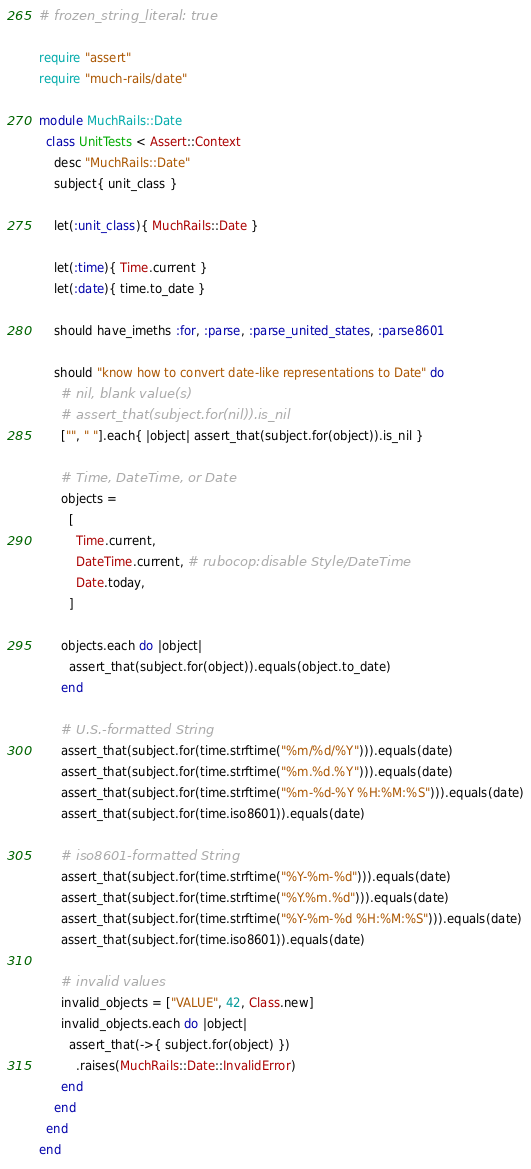<code> <loc_0><loc_0><loc_500><loc_500><_Ruby_># frozen_string_literal: true

require "assert"
require "much-rails/date"

module MuchRails::Date
  class UnitTests < Assert::Context
    desc "MuchRails::Date"
    subject{ unit_class }

    let(:unit_class){ MuchRails::Date }

    let(:time){ Time.current }
    let(:date){ time.to_date }

    should have_imeths :for, :parse, :parse_united_states, :parse8601

    should "know how to convert date-like representations to Date" do
      # nil, blank value(s)
      # assert_that(subject.for(nil)).is_nil
      ["", " "].each{ |object| assert_that(subject.for(object)).is_nil }

      # Time, DateTime, or Date
      objects =
        [
          Time.current,
          DateTime.current, # rubocop:disable Style/DateTime
          Date.today,
        ]

      objects.each do |object|
        assert_that(subject.for(object)).equals(object.to_date)
      end

      # U.S.-formatted String
      assert_that(subject.for(time.strftime("%m/%d/%Y"))).equals(date)
      assert_that(subject.for(time.strftime("%m.%d.%Y"))).equals(date)
      assert_that(subject.for(time.strftime("%m-%d-%Y %H:%M:%S"))).equals(date)
      assert_that(subject.for(time.iso8601)).equals(date)

      # iso8601-formatted String
      assert_that(subject.for(time.strftime("%Y-%m-%d"))).equals(date)
      assert_that(subject.for(time.strftime("%Y.%m.%d"))).equals(date)
      assert_that(subject.for(time.strftime("%Y-%m-%d %H:%M:%S"))).equals(date)
      assert_that(subject.for(time.iso8601)).equals(date)

      # invalid values
      invalid_objects = ["VALUE", 42, Class.new]
      invalid_objects.each do |object|
        assert_that(->{ subject.for(object) })
          .raises(MuchRails::Date::InvalidError)
      end
    end
  end
end
</code> 